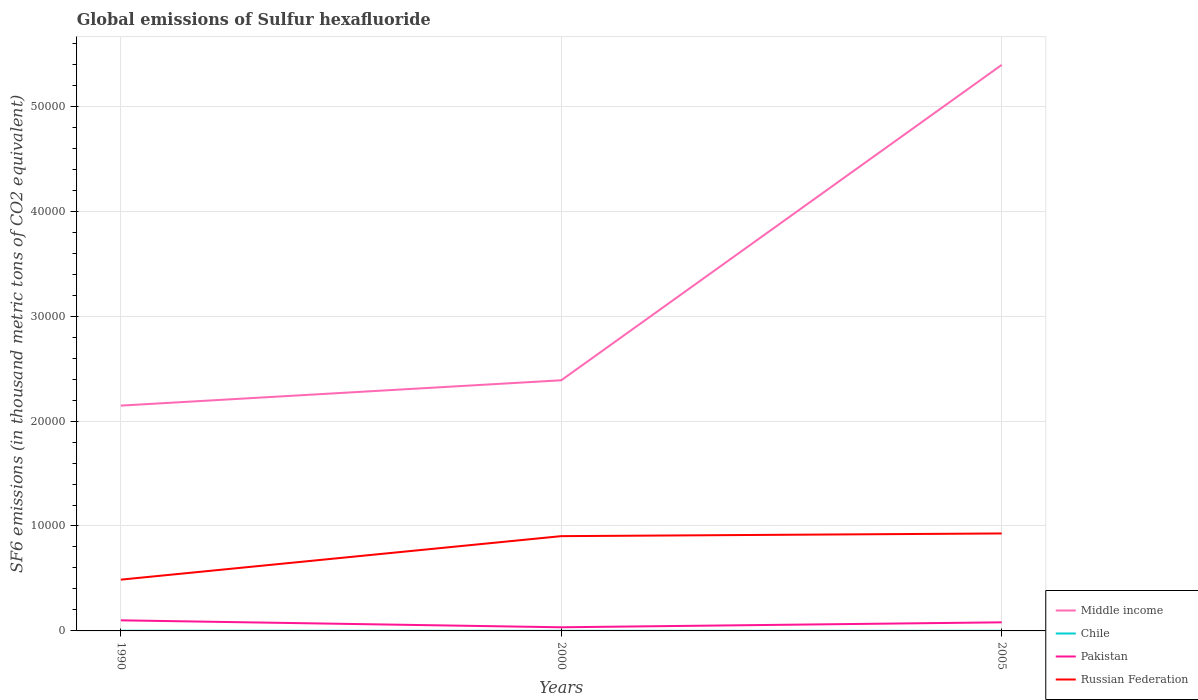Across all years, what is the maximum global emissions of Sulfur hexafluoride in Russian Federation?
Provide a succinct answer. 4886.8. What is the total global emissions of Sulfur hexafluoride in Chile in the graph?
Ensure brevity in your answer.  7.5. What is the difference between the highest and the second highest global emissions of Sulfur hexafluoride in Pakistan?
Provide a short and direct response. 661.8. What is the difference between two consecutive major ticks on the Y-axis?
Provide a short and direct response. 10000. Does the graph contain grids?
Keep it short and to the point. Yes. Where does the legend appear in the graph?
Provide a short and direct response. Bottom right. How many legend labels are there?
Provide a short and direct response. 4. What is the title of the graph?
Provide a succinct answer. Global emissions of Sulfur hexafluoride. What is the label or title of the Y-axis?
Provide a succinct answer. SF6 emissions (in thousand metric tons of CO2 equivalent). What is the SF6 emissions (in thousand metric tons of CO2 equivalent) of Middle income in 1990?
Your answer should be very brief. 2.15e+04. What is the SF6 emissions (in thousand metric tons of CO2 equivalent) of Chile in 1990?
Provide a succinct answer. 16.5. What is the SF6 emissions (in thousand metric tons of CO2 equivalent) of Pakistan in 1990?
Keep it short and to the point. 1009. What is the SF6 emissions (in thousand metric tons of CO2 equivalent) in Russian Federation in 1990?
Offer a terse response. 4886.8. What is the SF6 emissions (in thousand metric tons of CO2 equivalent) in Middle income in 2000?
Make the answer very short. 2.39e+04. What is the SF6 emissions (in thousand metric tons of CO2 equivalent) of Pakistan in 2000?
Keep it short and to the point. 347.2. What is the SF6 emissions (in thousand metric tons of CO2 equivalent) in Russian Federation in 2000?
Your answer should be very brief. 9033.2. What is the SF6 emissions (in thousand metric tons of CO2 equivalent) of Middle income in 2005?
Your answer should be compact. 5.39e+04. What is the SF6 emissions (in thousand metric tons of CO2 equivalent) in Pakistan in 2005?
Offer a very short reply. 819.4. What is the SF6 emissions (in thousand metric tons of CO2 equivalent) of Russian Federation in 2005?
Give a very brief answer. 9289.9. Across all years, what is the maximum SF6 emissions (in thousand metric tons of CO2 equivalent) in Middle income?
Your answer should be very brief. 5.39e+04. Across all years, what is the maximum SF6 emissions (in thousand metric tons of CO2 equivalent) of Chile?
Your response must be concise. 16.5. Across all years, what is the maximum SF6 emissions (in thousand metric tons of CO2 equivalent) of Pakistan?
Ensure brevity in your answer.  1009. Across all years, what is the maximum SF6 emissions (in thousand metric tons of CO2 equivalent) in Russian Federation?
Provide a succinct answer. 9289.9. Across all years, what is the minimum SF6 emissions (in thousand metric tons of CO2 equivalent) of Middle income?
Your response must be concise. 2.15e+04. Across all years, what is the minimum SF6 emissions (in thousand metric tons of CO2 equivalent) in Pakistan?
Give a very brief answer. 347.2. Across all years, what is the minimum SF6 emissions (in thousand metric tons of CO2 equivalent) in Russian Federation?
Give a very brief answer. 4886.8. What is the total SF6 emissions (in thousand metric tons of CO2 equivalent) of Middle income in the graph?
Your answer should be compact. 9.93e+04. What is the total SF6 emissions (in thousand metric tons of CO2 equivalent) in Chile in the graph?
Offer a very short reply. 32.2. What is the total SF6 emissions (in thousand metric tons of CO2 equivalent) of Pakistan in the graph?
Your answer should be compact. 2175.6. What is the total SF6 emissions (in thousand metric tons of CO2 equivalent) of Russian Federation in the graph?
Ensure brevity in your answer.  2.32e+04. What is the difference between the SF6 emissions (in thousand metric tons of CO2 equivalent) in Middle income in 1990 and that in 2000?
Your response must be concise. -2413.4. What is the difference between the SF6 emissions (in thousand metric tons of CO2 equivalent) in Chile in 1990 and that in 2000?
Offer a terse response. 9.8. What is the difference between the SF6 emissions (in thousand metric tons of CO2 equivalent) of Pakistan in 1990 and that in 2000?
Keep it short and to the point. 661.8. What is the difference between the SF6 emissions (in thousand metric tons of CO2 equivalent) of Russian Federation in 1990 and that in 2000?
Ensure brevity in your answer.  -4146.4. What is the difference between the SF6 emissions (in thousand metric tons of CO2 equivalent) of Middle income in 1990 and that in 2005?
Your response must be concise. -3.25e+04. What is the difference between the SF6 emissions (in thousand metric tons of CO2 equivalent) of Chile in 1990 and that in 2005?
Your answer should be compact. 7.5. What is the difference between the SF6 emissions (in thousand metric tons of CO2 equivalent) in Pakistan in 1990 and that in 2005?
Offer a terse response. 189.6. What is the difference between the SF6 emissions (in thousand metric tons of CO2 equivalent) in Russian Federation in 1990 and that in 2005?
Your answer should be very brief. -4403.1. What is the difference between the SF6 emissions (in thousand metric tons of CO2 equivalent) in Middle income in 2000 and that in 2005?
Give a very brief answer. -3.01e+04. What is the difference between the SF6 emissions (in thousand metric tons of CO2 equivalent) of Chile in 2000 and that in 2005?
Make the answer very short. -2.3. What is the difference between the SF6 emissions (in thousand metric tons of CO2 equivalent) of Pakistan in 2000 and that in 2005?
Offer a very short reply. -472.2. What is the difference between the SF6 emissions (in thousand metric tons of CO2 equivalent) in Russian Federation in 2000 and that in 2005?
Give a very brief answer. -256.7. What is the difference between the SF6 emissions (in thousand metric tons of CO2 equivalent) of Middle income in 1990 and the SF6 emissions (in thousand metric tons of CO2 equivalent) of Chile in 2000?
Ensure brevity in your answer.  2.15e+04. What is the difference between the SF6 emissions (in thousand metric tons of CO2 equivalent) in Middle income in 1990 and the SF6 emissions (in thousand metric tons of CO2 equivalent) in Pakistan in 2000?
Your answer should be very brief. 2.11e+04. What is the difference between the SF6 emissions (in thousand metric tons of CO2 equivalent) in Middle income in 1990 and the SF6 emissions (in thousand metric tons of CO2 equivalent) in Russian Federation in 2000?
Offer a terse response. 1.24e+04. What is the difference between the SF6 emissions (in thousand metric tons of CO2 equivalent) of Chile in 1990 and the SF6 emissions (in thousand metric tons of CO2 equivalent) of Pakistan in 2000?
Your answer should be compact. -330.7. What is the difference between the SF6 emissions (in thousand metric tons of CO2 equivalent) of Chile in 1990 and the SF6 emissions (in thousand metric tons of CO2 equivalent) of Russian Federation in 2000?
Make the answer very short. -9016.7. What is the difference between the SF6 emissions (in thousand metric tons of CO2 equivalent) of Pakistan in 1990 and the SF6 emissions (in thousand metric tons of CO2 equivalent) of Russian Federation in 2000?
Offer a very short reply. -8024.2. What is the difference between the SF6 emissions (in thousand metric tons of CO2 equivalent) in Middle income in 1990 and the SF6 emissions (in thousand metric tons of CO2 equivalent) in Chile in 2005?
Your response must be concise. 2.15e+04. What is the difference between the SF6 emissions (in thousand metric tons of CO2 equivalent) of Middle income in 1990 and the SF6 emissions (in thousand metric tons of CO2 equivalent) of Pakistan in 2005?
Give a very brief answer. 2.07e+04. What is the difference between the SF6 emissions (in thousand metric tons of CO2 equivalent) of Middle income in 1990 and the SF6 emissions (in thousand metric tons of CO2 equivalent) of Russian Federation in 2005?
Your answer should be compact. 1.22e+04. What is the difference between the SF6 emissions (in thousand metric tons of CO2 equivalent) in Chile in 1990 and the SF6 emissions (in thousand metric tons of CO2 equivalent) in Pakistan in 2005?
Provide a short and direct response. -802.9. What is the difference between the SF6 emissions (in thousand metric tons of CO2 equivalent) in Chile in 1990 and the SF6 emissions (in thousand metric tons of CO2 equivalent) in Russian Federation in 2005?
Keep it short and to the point. -9273.4. What is the difference between the SF6 emissions (in thousand metric tons of CO2 equivalent) of Pakistan in 1990 and the SF6 emissions (in thousand metric tons of CO2 equivalent) of Russian Federation in 2005?
Offer a very short reply. -8280.9. What is the difference between the SF6 emissions (in thousand metric tons of CO2 equivalent) of Middle income in 2000 and the SF6 emissions (in thousand metric tons of CO2 equivalent) of Chile in 2005?
Give a very brief answer. 2.39e+04. What is the difference between the SF6 emissions (in thousand metric tons of CO2 equivalent) of Middle income in 2000 and the SF6 emissions (in thousand metric tons of CO2 equivalent) of Pakistan in 2005?
Provide a short and direct response. 2.31e+04. What is the difference between the SF6 emissions (in thousand metric tons of CO2 equivalent) of Middle income in 2000 and the SF6 emissions (in thousand metric tons of CO2 equivalent) of Russian Federation in 2005?
Ensure brevity in your answer.  1.46e+04. What is the difference between the SF6 emissions (in thousand metric tons of CO2 equivalent) in Chile in 2000 and the SF6 emissions (in thousand metric tons of CO2 equivalent) in Pakistan in 2005?
Provide a succinct answer. -812.7. What is the difference between the SF6 emissions (in thousand metric tons of CO2 equivalent) in Chile in 2000 and the SF6 emissions (in thousand metric tons of CO2 equivalent) in Russian Federation in 2005?
Ensure brevity in your answer.  -9283.2. What is the difference between the SF6 emissions (in thousand metric tons of CO2 equivalent) of Pakistan in 2000 and the SF6 emissions (in thousand metric tons of CO2 equivalent) of Russian Federation in 2005?
Your answer should be compact. -8942.7. What is the average SF6 emissions (in thousand metric tons of CO2 equivalent) in Middle income per year?
Your answer should be compact. 3.31e+04. What is the average SF6 emissions (in thousand metric tons of CO2 equivalent) of Chile per year?
Give a very brief answer. 10.73. What is the average SF6 emissions (in thousand metric tons of CO2 equivalent) of Pakistan per year?
Keep it short and to the point. 725.2. What is the average SF6 emissions (in thousand metric tons of CO2 equivalent) in Russian Federation per year?
Offer a terse response. 7736.63. In the year 1990, what is the difference between the SF6 emissions (in thousand metric tons of CO2 equivalent) in Middle income and SF6 emissions (in thousand metric tons of CO2 equivalent) in Chile?
Offer a very short reply. 2.15e+04. In the year 1990, what is the difference between the SF6 emissions (in thousand metric tons of CO2 equivalent) in Middle income and SF6 emissions (in thousand metric tons of CO2 equivalent) in Pakistan?
Your answer should be compact. 2.05e+04. In the year 1990, what is the difference between the SF6 emissions (in thousand metric tons of CO2 equivalent) in Middle income and SF6 emissions (in thousand metric tons of CO2 equivalent) in Russian Federation?
Your answer should be very brief. 1.66e+04. In the year 1990, what is the difference between the SF6 emissions (in thousand metric tons of CO2 equivalent) of Chile and SF6 emissions (in thousand metric tons of CO2 equivalent) of Pakistan?
Make the answer very short. -992.5. In the year 1990, what is the difference between the SF6 emissions (in thousand metric tons of CO2 equivalent) in Chile and SF6 emissions (in thousand metric tons of CO2 equivalent) in Russian Federation?
Your response must be concise. -4870.3. In the year 1990, what is the difference between the SF6 emissions (in thousand metric tons of CO2 equivalent) in Pakistan and SF6 emissions (in thousand metric tons of CO2 equivalent) in Russian Federation?
Ensure brevity in your answer.  -3877.8. In the year 2000, what is the difference between the SF6 emissions (in thousand metric tons of CO2 equivalent) in Middle income and SF6 emissions (in thousand metric tons of CO2 equivalent) in Chile?
Keep it short and to the point. 2.39e+04. In the year 2000, what is the difference between the SF6 emissions (in thousand metric tons of CO2 equivalent) in Middle income and SF6 emissions (in thousand metric tons of CO2 equivalent) in Pakistan?
Offer a very short reply. 2.35e+04. In the year 2000, what is the difference between the SF6 emissions (in thousand metric tons of CO2 equivalent) of Middle income and SF6 emissions (in thousand metric tons of CO2 equivalent) of Russian Federation?
Offer a terse response. 1.49e+04. In the year 2000, what is the difference between the SF6 emissions (in thousand metric tons of CO2 equivalent) in Chile and SF6 emissions (in thousand metric tons of CO2 equivalent) in Pakistan?
Offer a terse response. -340.5. In the year 2000, what is the difference between the SF6 emissions (in thousand metric tons of CO2 equivalent) of Chile and SF6 emissions (in thousand metric tons of CO2 equivalent) of Russian Federation?
Your response must be concise. -9026.5. In the year 2000, what is the difference between the SF6 emissions (in thousand metric tons of CO2 equivalent) in Pakistan and SF6 emissions (in thousand metric tons of CO2 equivalent) in Russian Federation?
Provide a succinct answer. -8686. In the year 2005, what is the difference between the SF6 emissions (in thousand metric tons of CO2 equivalent) of Middle income and SF6 emissions (in thousand metric tons of CO2 equivalent) of Chile?
Offer a very short reply. 5.39e+04. In the year 2005, what is the difference between the SF6 emissions (in thousand metric tons of CO2 equivalent) in Middle income and SF6 emissions (in thousand metric tons of CO2 equivalent) in Pakistan?
Provide a succinct answer. 5.31e+04. In the year 2005, what is the difference between the SF6 emissions (in thousand metric tons of CO2 equivalent) of Middle income and SF6 emissions (in thousand metric tons of CO2 equivalent) of Russian Federation?
Keep it short and to the point. 4.47e+04. In the year 2005, what is the difference between the SF6 emissions (in thousand metric tons of CO2 equivalent) in Chile and SF6 emissions (in thousand metric tons of CO2 equivalent) in Pakistan?
Your answer should be compact. -810.4. In the year 2005, what is the difference between the SF6 emissions (in thousand metric tons of CO2 equivalent) in Chile and SF6 emissions (in thousand metric tons of CO2 equivalent) in Russian Federation?
Make the answer very short. -9280.9. In the year 2005, what is the difference between the SF6 emissions (in thousand metric tons of CO2 equivalent) in Pakistan and SF6 emissions (in thousand metric tons of CO2 equivalent) in Russian Federation?
Give a very brief answer. -8470.5. What is the ratio of the SF6 emissions (in thousand metric tons of CO2 equivalent) in Middle income in 1990 to that in 2000?
Provide a short and direct response. 0.9. What is the ratio of the SF6 emissions (in thousand metric tons of CO2 equivalent) in Chile in 1990 to that in 2000?
Make the answer very short. 2.46. What is the ratio of the SF6 emissions (in thousand metric tons of CO2 equivalent) of Pakistan in 1990 to that in 2000?
Your answer should be compact. 2.91. What is the ratio of the SF6 emissions (in thousand metric tons of CO2 equivalent) of Russian Federation in 1990 to that in 2000?
Your response must be concise. 0.54. What is the ratio of the SF6 emissions (in thousand metric tons of CO2 equivalent) of Middle income in 1990 to that in 2005?
Your response must be concise. 0.4. What is the ratio of the SF6 emissions (in thousand metric tons of CO2 equivalent) in Chile in 1990 to that in 2005?
Make the answer very short. 1.83. What is the ratio of the SF6 emissions (in thousand metric tons of CO2 equivalent) in Pakistan in 1990 to that in 2005?
Keep it short and to the point. 1.23. What is the ratio of the SF6 emissions (in thousand metric tons of CO2 equivalent) in Russian Federation in 1990 to that in 2005?
Make the answer very short. 0.53. What is the ratio of the SF6 emissions (in thousand metric tons of CO2 equivalent) in Middle income in 2000 to that in 2005?
Provide a succinct answer. 0.44. What is the ratio of the SF6 emissions (in thousand metric tons of CO2 equivalent) of Chile in 2000 to that in 2005?
Provide a short and direct response. 0.74. What is the ratio of the SF6 emissions (in thousand metric tons of CO2 equivalent) of Pakistan in 2000 to that in 2005?
Provide a succinct answer. 0.42. What is the ratio of the SF6 emissions (in thousand metric tons of CO2 equivalent) in Russian Federation in 2000 to that in 2005?
Make the answer very short. 0.97. What is the difference between the highest and the second highest SF6 emissions (in thousand metric tons of CO2 equivalent) in Middle income?
Offer a very short reply. 3.01e+04. What is the difference between the highest and the second highest SF6 emissions (in thousand metric tons of CO2 equivalent) in Chile?
Offer a very short reply. 7.5. What is the difference between the highest and the second highest SF6 emissions (in thousand metric tons of CO2 equivalent) in Pakistan?
Make the answer very short. 189.6. What is the difference between the highest and the second highest SF6 emissions (in thousand metric tons of CO2 equivalent) of Russian Federation?
Give a very brief answer. 256.7. What is the difference between the highest and the lowest SF6 emissions (in thousand metric tons of CO2 equivalent) in Middle income?
Ensure brevity in your answer.  3.25e+04. What is the difference between the highest and the lowest SF6 emissions (in thousand metric tons of CO2 equivalent) of Pakistan?
Make the answer very short. 661.8. What is the difference between the highest and the lowest SF6 emissions (in thousand metric tons of CO2 equivalent) of Russian Federation?
Offer a terse response. 4403.1. 